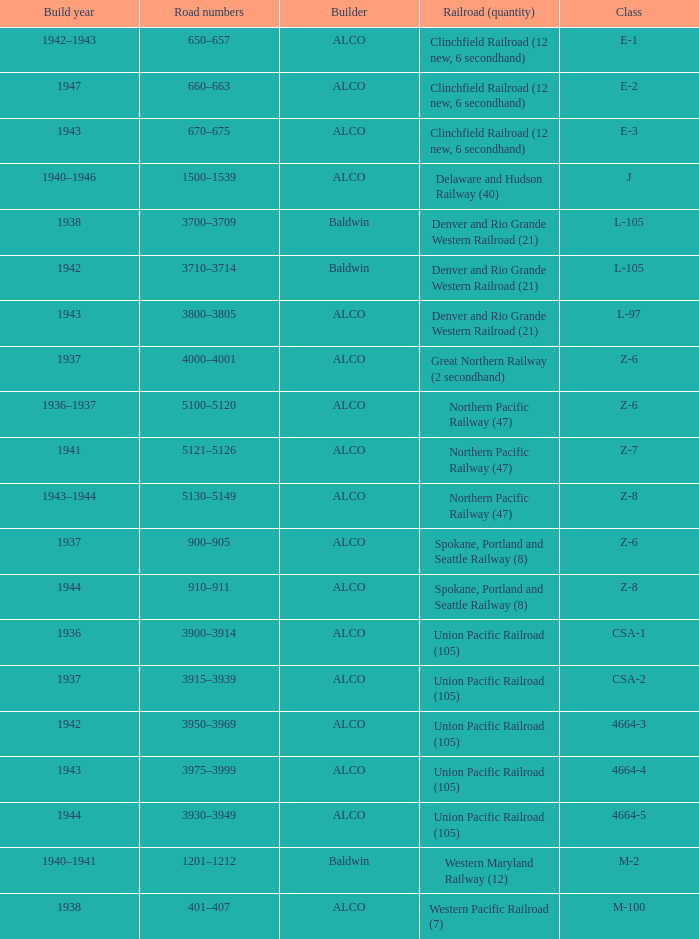What is the road numbers when the builder is alco, the railroad (quantity) is union pacific railroad (105) and the class is csa-2? 3915–3939. Could you help me parse every detail presented in this table? {'header': ['Build year', 'Road numbers', 'Builder', 'Railroad (quantity)', 'Class'], 'rows': [['1942–1943', '650–657', 'ALCO', 'Clinchfield Railroad (12 new, 6 secondhand)', 'E-1'], ['1947', '660–663', 'ALCO', 'Clinchfield Railroad (12 new, 6 secondhand)', 'E-2'], ['1943', '670–675', 'ALCO', 'Clinchfield Railroad (12 new, 6 secondhand)', 'E-3'], ['1940–1946', '1500–1539', 'ALCO', 'Delaware and Hudson Railway (40)', 'J'], ['1938', '3700–3709', 'Baldwin', 'Denver and Rio Grande Western Railroad (21)', 'L-105'], ['1942', '3710–3714', 'Baldwin', 'Denver and Rio Grande Western Railroad (21)', 'L-105'], ['1943', '3800–3805', 'ALCO', 'Denver and Rio Grande Western Railroad (21)', 'L-97'], ['1937', '4000–4001', 'ALCO', 'Great Northern Railway (2 secondhand)', 'Z-6'], ['1936–1937', '5100–5120', 'ALCO', 'Northern Pacific Railway (47)', 'Z-6'], ['1941', '5121–5126', 'ALCO', 'Northern Pacific Railway (47)', 'Z-7'], ['1943–1944', '5130–5149', 'ALCO', 'Northern Pacific Railway (47)', 'Z-8'], ['1937', '900–905', 'ALCO', 'Spokane, Portland and Seattle Railway (8)', 'Z-6'], ['1944', '910–911', 'ALCO', 'Spokane, Portland and Seattle Railway (8)', 'Z-8'], ['1936', '3900–3914', 'ALCO', 'Union Pacific Railroad (105)', 'CSA-1'], ['1937', '3915–3939', 'ALCO', 'Union Pacific Railroad (105)', 'CSA-2'], ['1942', '3950–3969', 'ALCO', 'Union Pacific Railroad (105)', '4664-3'], ['1943', '3975–3999', 'ALCO', 'Union Pacific Railroad (105)', '4664-4'], ['1944', '3930–3949', 'ALCO', 'Union Pacific Railroad (105)', '4664-5'], ['1940–1941', '1201–1212', 'Baldwin', 'Western Maryland Railway (12)', 'M-2'], ['1938', '401–407', 'ALCO', 'Western Pacific Railroad (7)', 'M-100']]} 